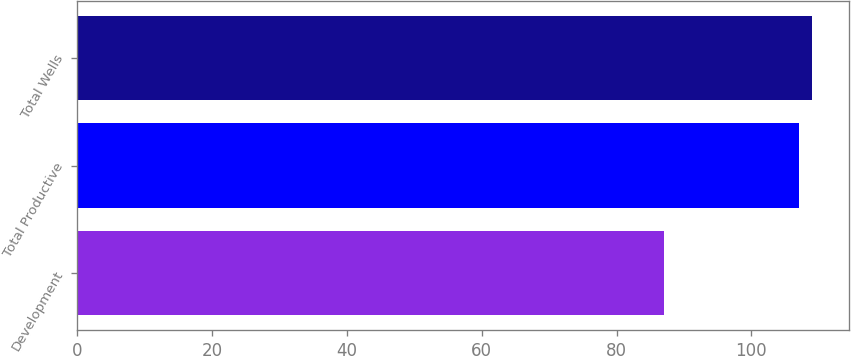<chart> <loc_0><loc_0><loc_500><loc_500><bar_chart><fcel>Development<fcel>Total Productive<fcel>Total Wells<nl><fcel>87<fcel>107<fcel>109<nl></chart> 